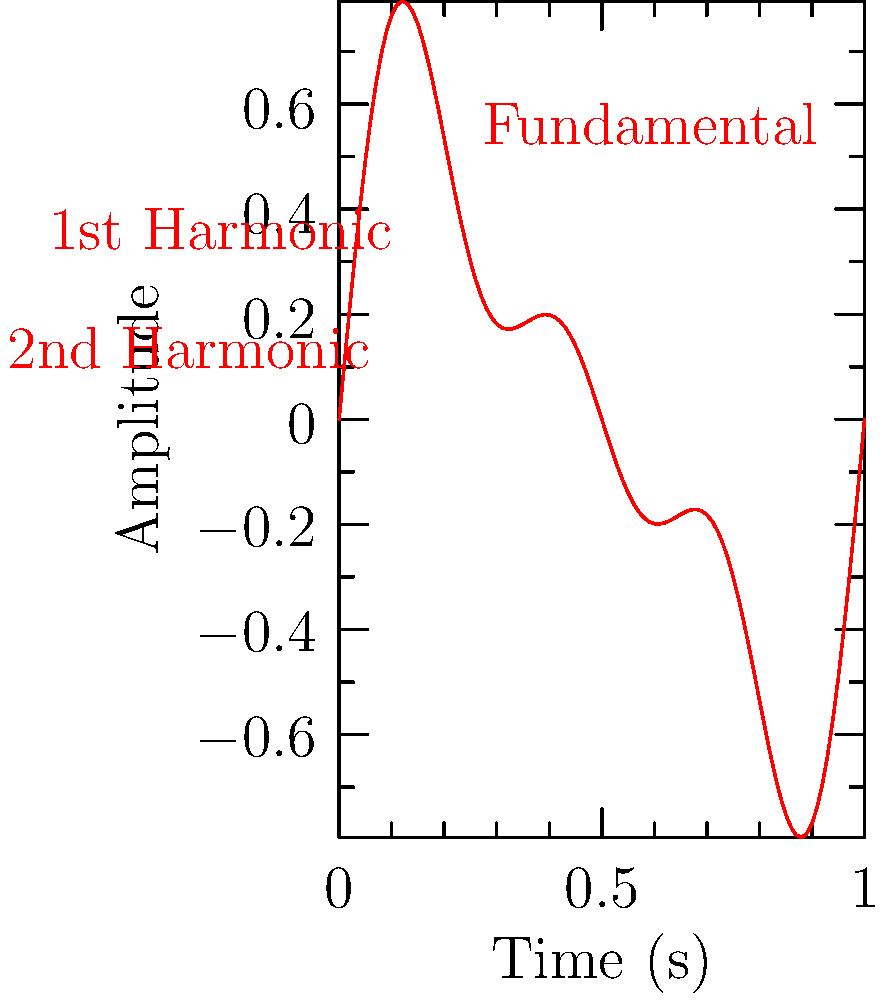Analyze the waveform representation of a traditional Scottish bagpipe melody shown above. What characteristic of the bagpipe sound does this waveform illustrate, and how does it relate to the instrument's unique timbre? To answer this question, let's analyze the waveform step-by-step:

1. The waveform shows a complex periodic pattern, which is a combination of multiple sine waves.

2. We can identify three main components:
   a) A fundamental frequency (labeled "Fundamental")
   b) A first harmonic (labeled "1st Harmonic")
   c) A second harmonic (labeled "2nd Harmonic")

3. The presence of these harmonics is crucial in understanding the bagpipe's timbre:
   a) The fundamental frequency represents the base pitch of the note.
   b) The harmonics are integer multiples of the fundamental frequency.

4. In this case, we see that:
   a) The fundamental has the largest amplitude (0.5)
   b) The first harmonic has a smaller amplitude (0.3)
   c) The second harmonic has the smallest amplitude (0.2)

5. This distribution of amplitudes across harmonics is characteristic of the bagpipe's sound:
   a) It creates a rich, complex timbre
   b) The strong presence of harmonics gives the bagpipe its distinctive "reedy" quality

6. The steady-state nature of the waveform (no significant changes in amplitude over time) reflects the bagpipe's continuous sound production method:
   a) Air is constantly supplied to the reed from the bag
   b) This results in a sustained, unwavering tone

7. The lack of attack or decay in the waveform is also typical of bagpipe sound:
   a) Notes start and stop abruptly
   b) This contributes to the instrument's unique articulation and phrasing capabilities

In conclusion, this waveform illustrates the harmonic richness and steady-state nature of the bagpipe sound, which are key factors in its distinctive timbre and playing characteristics.
Answer: Harmonic richness and steady-state sound production 